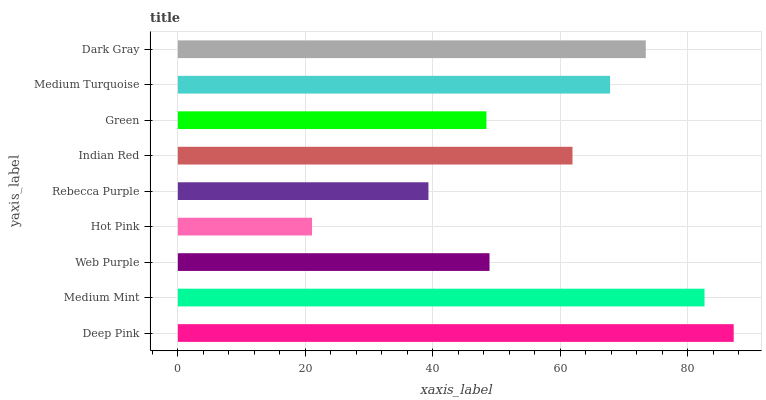Is Hot Pink the minimum?
Answer yes or no. Yes. Is Deep Pink the maximum?
Answer yes or no. Yes. Is Medium Mint the minimum?
Answer yes or no. No. Is Medium Mint the maximum?
Answer yes or no. No. Is Deep Pink greater than Medium Mint?
Answer yes or no. Yes. Is Medium Mint less than Deep Pink?
Answer yes or no. Yes. Is Medium Mint greater than Deep Pink?
Answer yes or no. No. Is Deep Pink less than Medium Mint?
Answer yes or no. No. Is Indian Red the high median?
Answer yes or no. Yes. Is Indian Red the low median?
Answer yes or no. Yes. Is Medium Mint the high median?
Answer yes or no. No. Is Medium Mint the low median?
Answer yes or no. No. 